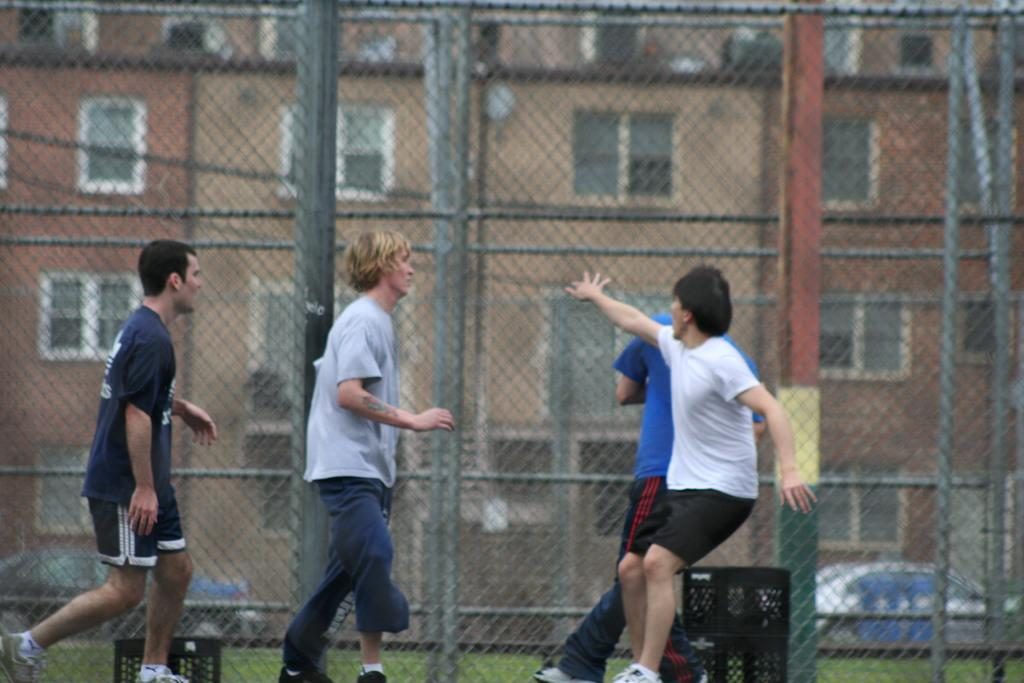How many men are present in the image? There are 4 men in the image. What can be seen in the image besides the men? There are 2 black color cans visible in the image. What is visible in the background of the image? Fencing, buildings, and cars are visible in the background of the image. What type of reaction can be seen happening with the butter in the image? There is no butter present in the image, so no reaction involving butter can be observed. 